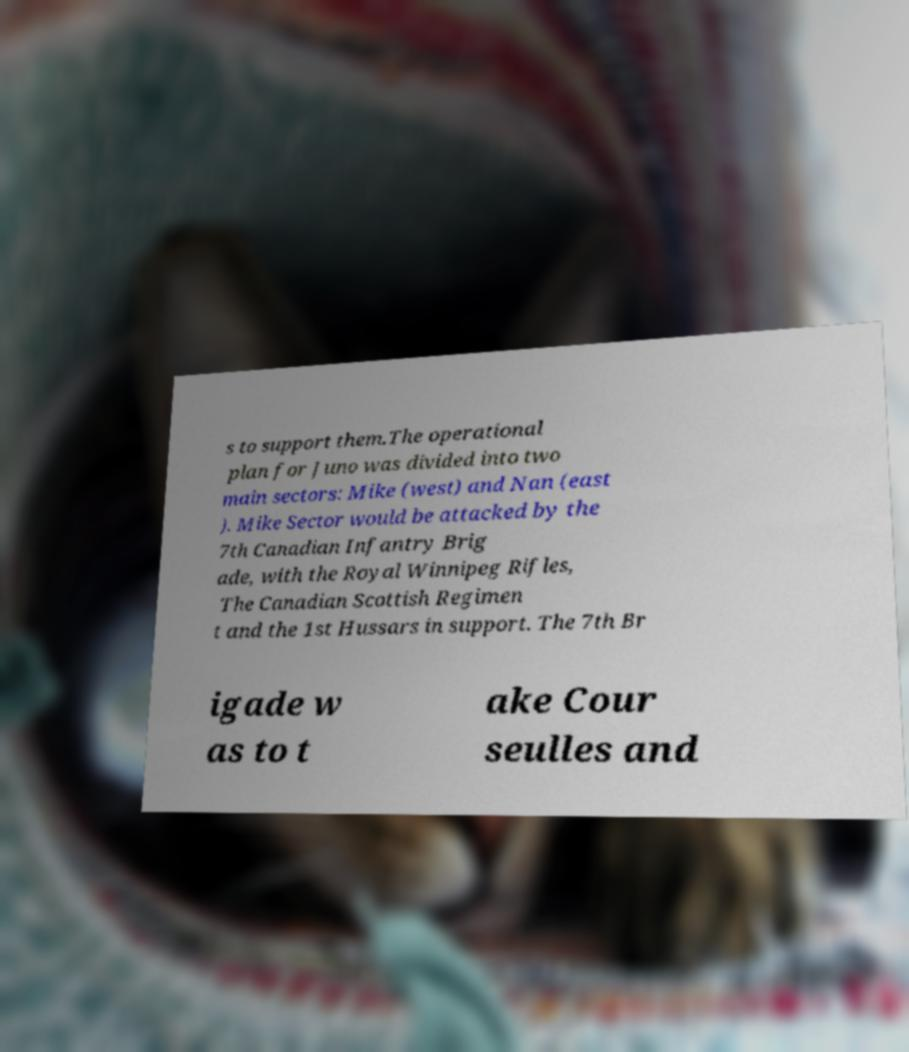Please identify and transcribe the text found in this image. s to support them.The operational plan for Juno was divided into two main sectors: Mike (west) and Nan (east ). Mike Sector would be attacked by the 7th Canadian Infantry Brig ade, with the Royal Winnipeg Rifles, The Canadian Scottish Regimen t and the 1st Hussars in support. The 7th Br igade w as to t ake Cour seulles and 